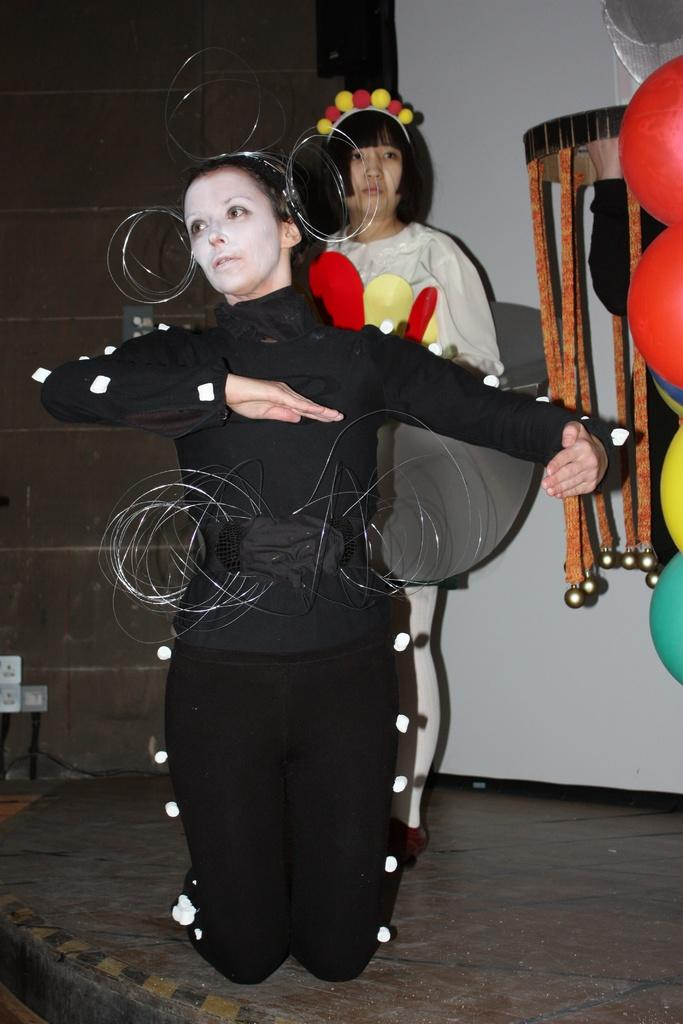Who or what can be seen in the image? There are people in the image. Where are the people located in the image? The people are on the floor. What else is present in the image besides the people? There are balloons in the image. Can you describe any other objects in the image? There are objects in the image, but their specific nature is not mentioned in the provided facts. How many times does the number 7 appear in the image? The provided facts do not mention any numbers or the number 7, so it cannot be determined from the image. 